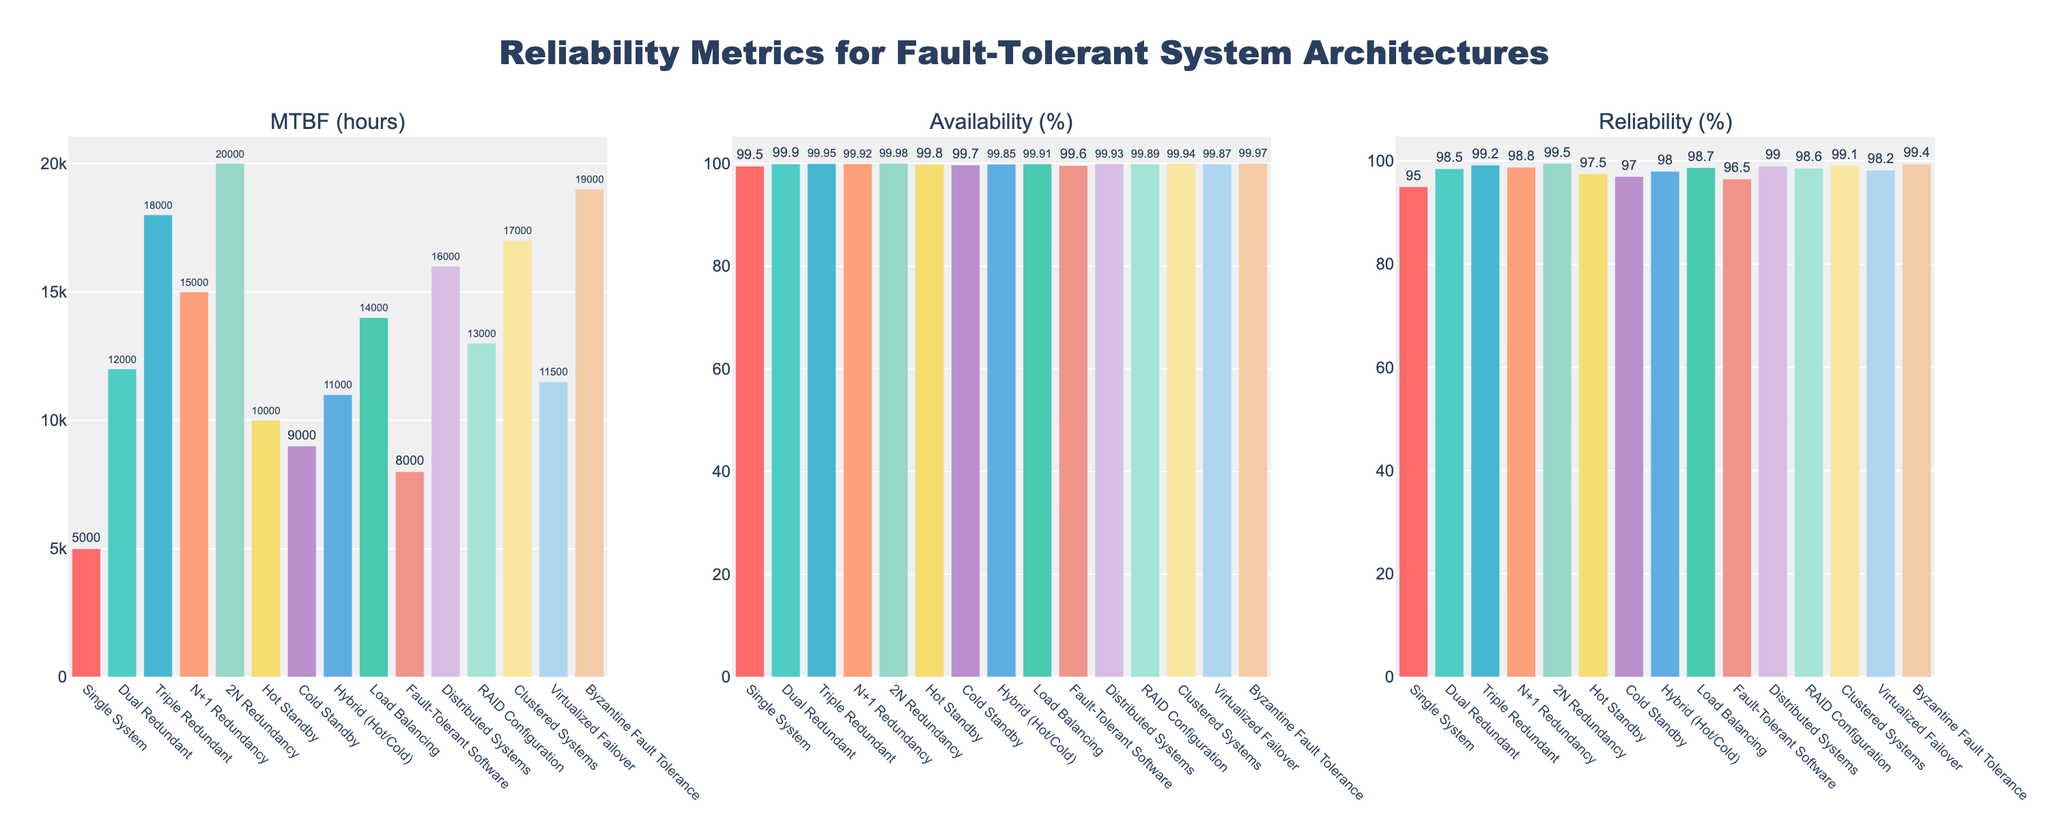Which architecture has the highest MTBF (Mean Time Between Failures)? To determine the architecture with the highest MTBF, look at the height of the bars in the first subplot (MTBF). The tallest bar represents the highest MTBF value.
Answer: 2N Redundancy Which architecture has the lowest availability percentage? To find the lowest availability percentage, examine the heights of the bars in the second subplot (Availability %). The shortest bar corresponds to the lowest value.
Answer: Single System Which architecture has better reliability: "Dual Redundant" or "Fault-Tolerant Software"? Compare the heights of the bars for "Reliability (%)" in the third subplot for both architectures. "Dual Redundant" has a higher bar compared to "Fault-Tolerant Software".
Answer: Dual Redundant What is the average MTBF of the architectures "Single System", "Dual Redundant", and "Triple Redundant"? Add the MTBF values for these architectures (5000, 12000, 18000), then divide by the number of architectures (3). (5000 + 12000 + 18000) / 3 = 11666.67
Answer: 11666.67 How much more reliable is "Byzantine Fault Tolerance" compared to "Hot Standby"? Subtract the reliability percentage of "Hot Standby" from that of "Byzantine Fault Tolerance". 99.4% - 97.5% = 1.9%
Answer: 1.9% Which architecture has a higher MTBF: "Hybrid (Hot/Cold)" or "Virtualized Failover"? Compare the heights of the bars for these architectures in the first subplot (MTBF). "Virtualized Failover" has a higher bar compared to "Hybrid (Hot/Cold)".
Answer: Virtualized Failover What is the ratio of the availability of "Distributed Systems" to "Cold Standby"? Divide the availability percentage of "Distributed Systems" by that of "Cold Standby". 99.93 / 99.7 ≈ 1.0023
Answer: ~1.0023 What is the difference in reliability between "Load Balancing" and "Clustered Systems"? Subtract the reliability percentage of "Load Balancing" from that of "Clustered Systems". 99.1% - 98.7% = 0.4%
Answer: 0.4% Which architecture among "RAID Configuration" and "Hot Standby" has a higher availability percentage? Compare the heights of the bars for these architectures in the second subplot (Availability %). "RAID Configuration" has a higher bar.
Answer: RAID Configuration 